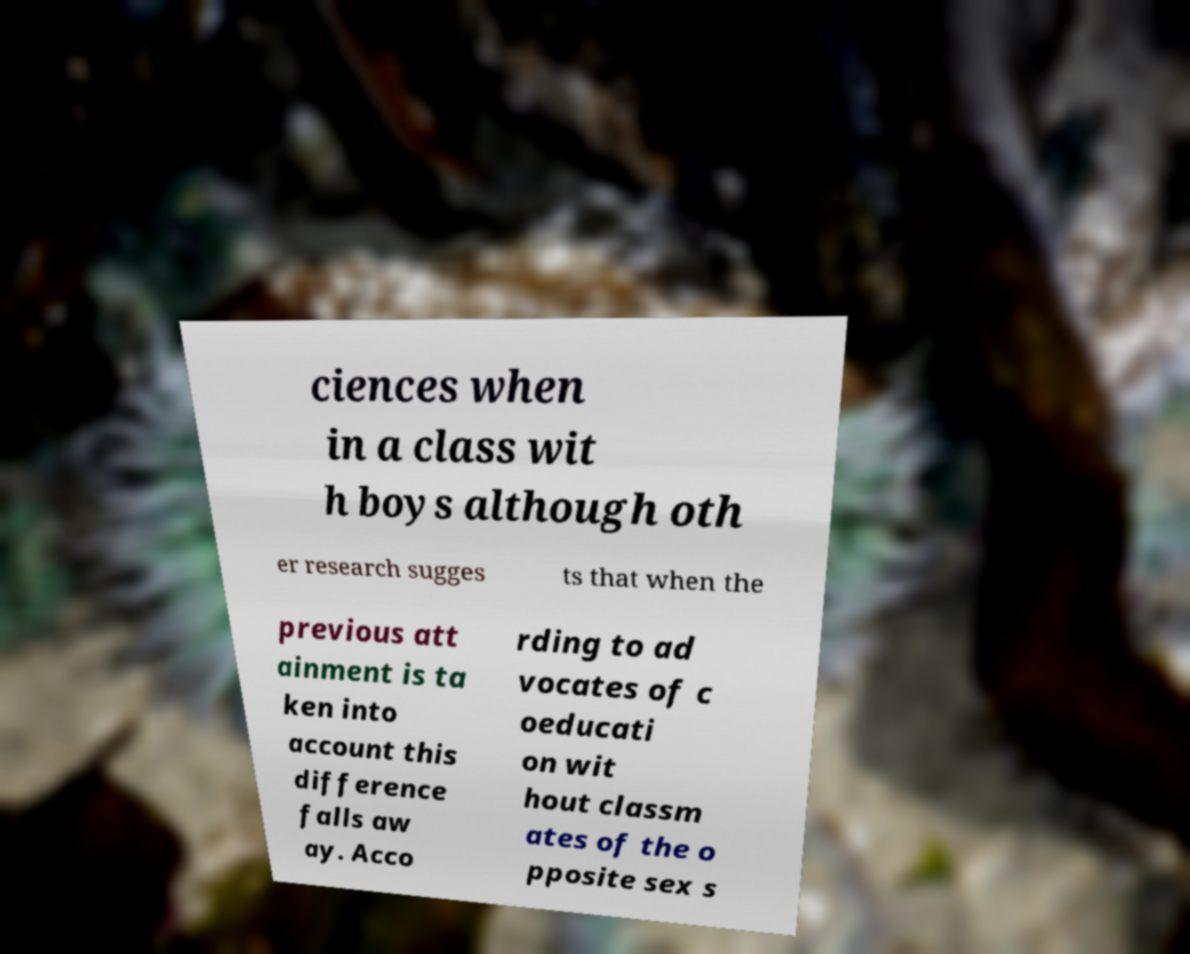For documentation purposes, I need the text within this image transcribed. Could you provide that? ciences when in a class wit h boys although oth er research sugges ts that when the previous att ainment is ta ken into account this difference falls aw ay. Acco rding to ad vocates of c oeducati on wit hout classm ates of the o pposite sex s 